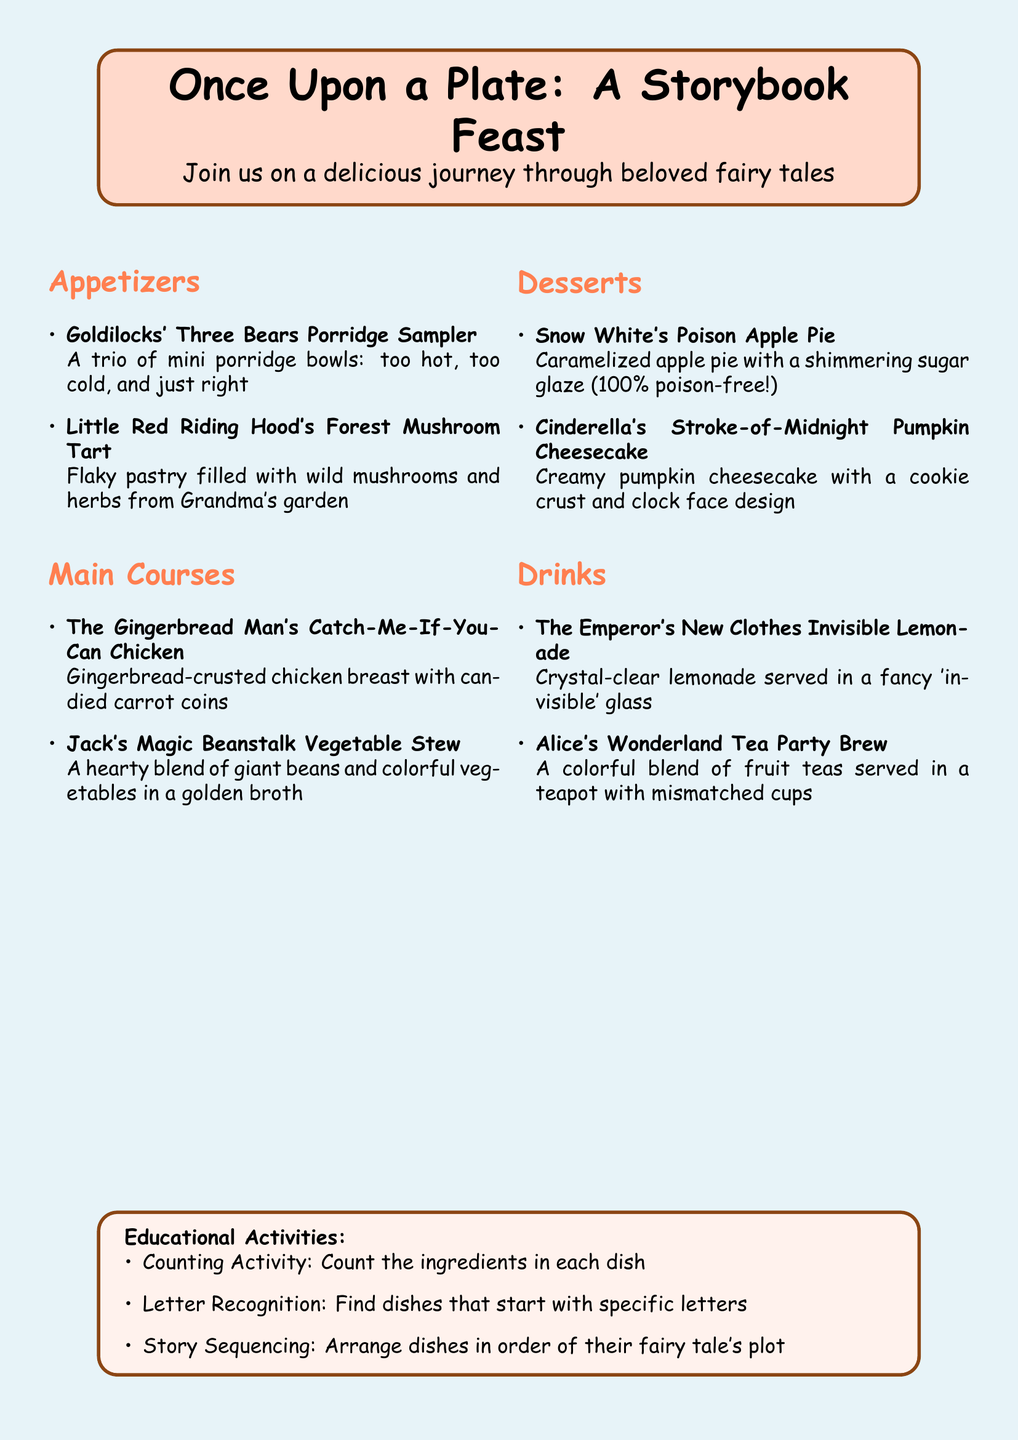What is the title of the menu? The title of the menu is prominently displayed at the beginning of the document.
Answer: Once Upon a Plate: A Storybook Feast How many appetizers are listed? The document includes a section for appetizers with a specific number of items listed.
Answer: 2 What is the first dessert mentioned? The first dessert is part of the dessert section, which lists items with their names.
Answer: Snow White's Poison Apple Pie Which fairy tale is associated with the chicken dish? The chicken dish has a title directly referencing a famous fairy tale character.
Answer: The Gingerbread Man What type of drink does the menu describe as "invisible"? The drink section features a description of a unique drink presented in a whimsical way.
Answer: Invisible Lemonade How many educational activities are suggested? The educational activities section lists a specific number of activities for interaction.
Answer: 3 What color is the background of the menu page? The overall page color is mentioned at the beginning of the document.
Answer: Light blue What is the key ingredient in Cinderella's dessert? The dessert titled Cinderella's provides information on its main component.
Answer: Pumpkin Which fairy tale involves a forest mushroom tart? The dish associated with mushrooms in the title references a character from a fairy tale.
Answer: Little Red Riding Hood 